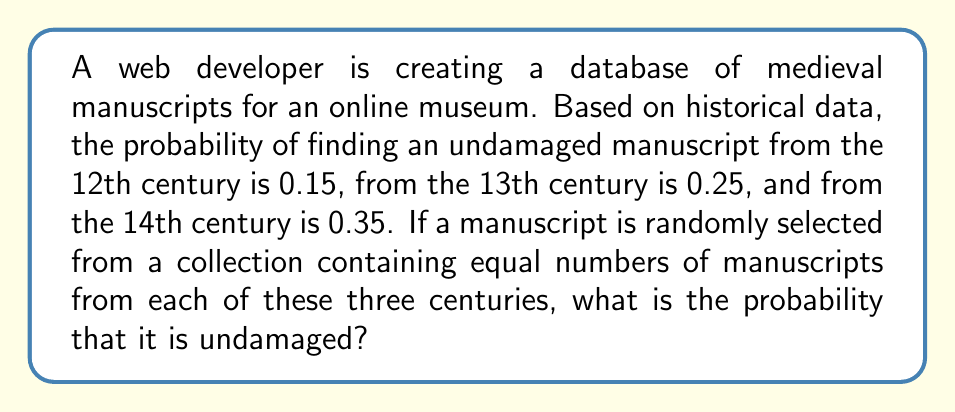What is the answer to this math problem? Let's approach this step-by-step:

1) First, we need to understand what the question is asking. We're looking for the overall probability of selecting an undamaged manuscript from a collection that contains equal numbers of manuscripts from the 12th, 13th, and 14th centuries.

2) We're given the following probabilities:
   - P(undamaged | 12th century) = 0.15
   - P(undamaged | 13th century) = 0.25
   - P(undamaged | 14th century) = 0.35

3) Since the collection contains equal numbers of manuscripts from each century, the probability of selecting a manuscript from any particular century is 1/3.

4) We can use the law of total probability to solve this problem. The formula is:

   $$P(A) = \sum_{i} P(A|B_i) \cdot P(B_i)$$

   Where A is the event of selecting an undamaged manuscript, and $B_i$ are the mutually exclusive events of selecting a manuscript from each century.

5) Applying the formula:

   $$P(\text{undamaged}) = P(\text{undamaged | 12th}) \cdot P(\text{12th}) + P(\text{undamaged | 13th}) \cdot P(\text{13th}) + P(\text{undamaged | 14th}) \cdot P(\text{14th})$$

6) Substituting the values:

   $$P(\text{undamaged}) = 0.15 \cdot \frac{1}{3} + 0.25 \cdot \frac{1}{3} + 0.35 \cdot \frac{1}{3}$$

7) Simplifying:

   $$P(\text{undamaged}) = \frac{0.15 + 0.25 + 0.35}{3} = \frac{0.75}{3} = 0.25$$

Therefore, the probability of randomly selecting an undamaged manuscript from this collection is 0.25 or 25%.
Answer: 0.25 